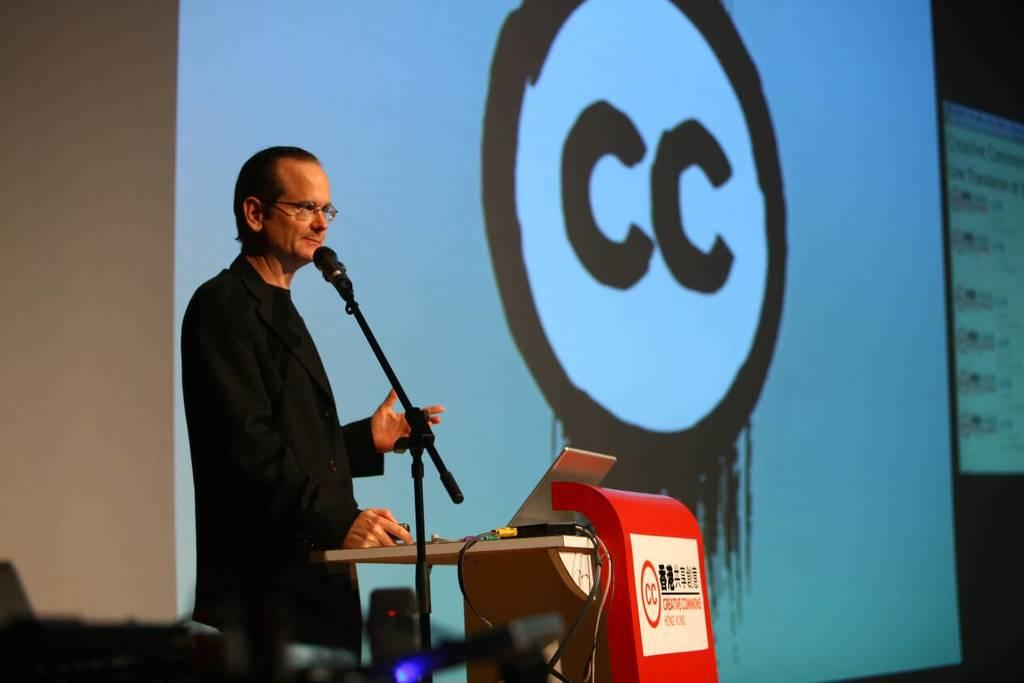What is the main subject of the image? There is a man standing in the image. Can you describe the man's appearance? The man is wearing clothes and spectacles. What objects are present in the image related to a presentation or speech? There is a podium, a microphone, and a projected screen in the image. Are there any visible cables or wires in the image? Yes, there are cable wires in the image. What type of background can be seen in the image? There is a wall in the image. What type of farm animals can be seen in the image? There are no farm animals present in the image. Is the man downtown in the image? The provided facts do not mention the location as being downtown, so we cannot determine if the man is downtown from the image. 